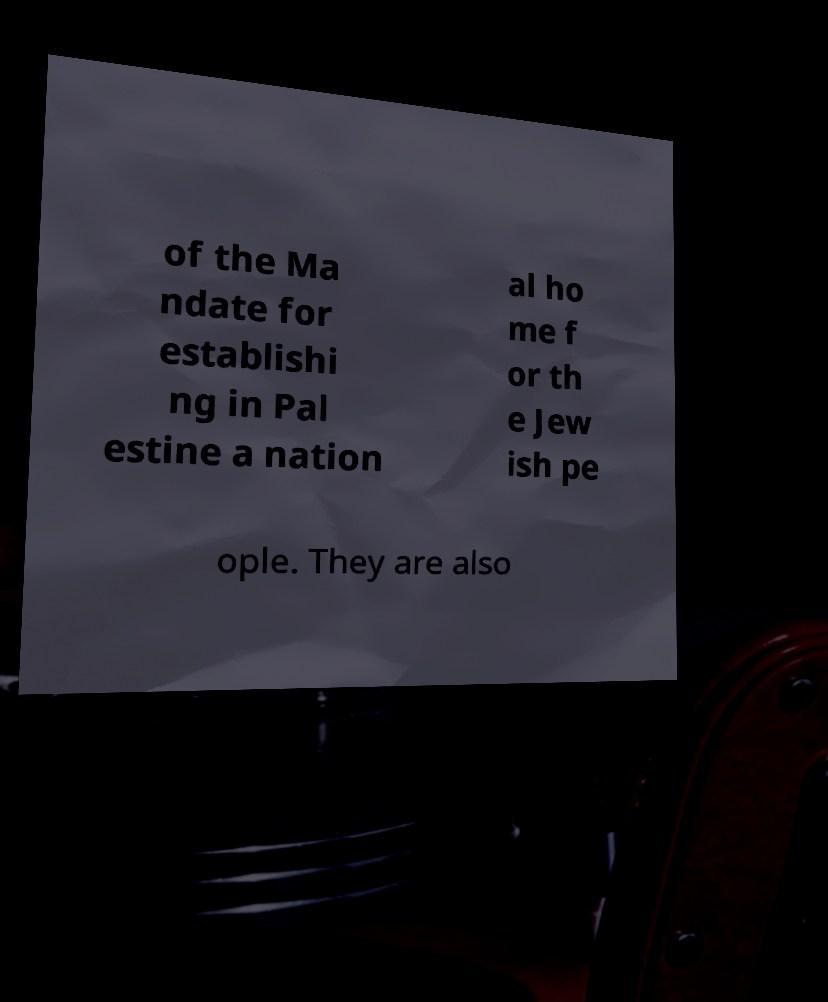Could you extract and type out the text from this image? of the Ma ndate for establishi ng in Pal estine a nation al ho me f or th e Jew ish pe ople. They are also 